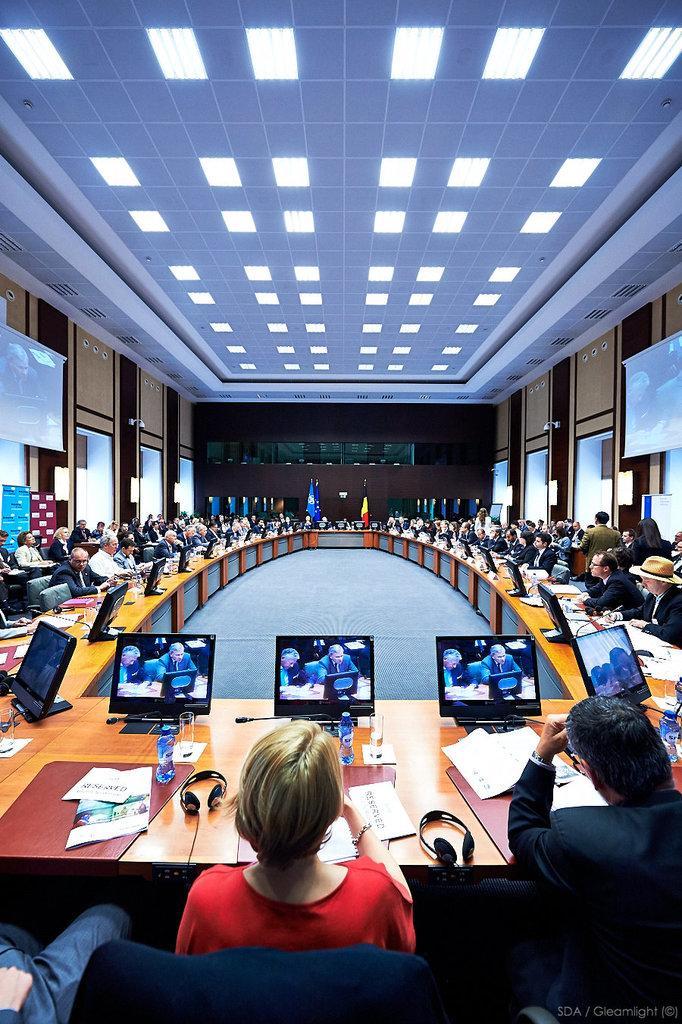How would you summarize this image in a sentence or two? In the picture we can see a conference hall with many people sitting near the desk and on the desk, we can see computer systems, headsets, papers, water bottles and glasses and in the background, we can see a wall which is brown in color and to the side wall with some screens to it and to the ceiling we can see the lights. 